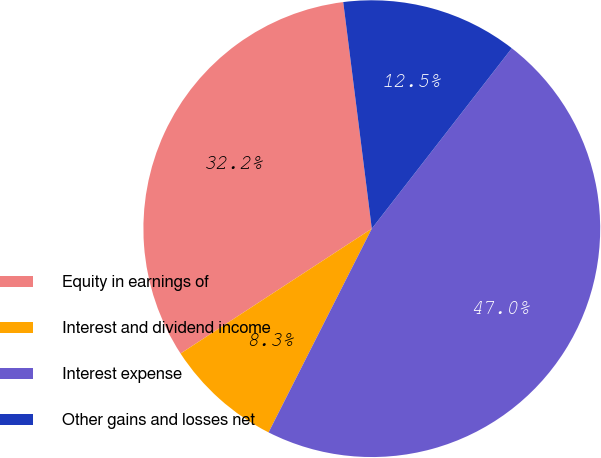Convert chart to OTSL. <chart><loc_0><loc_0><loc_500><loc_500><pie_chart><fcel>Equity in earnings of<fcel>Interest and dividend income<fcel>Interest expense<fcel>Other gains and losses net<nl><fcel>32.21%<fcel>8.33%<fcel>46.96%<fcel>12.5%<nl></chart> 